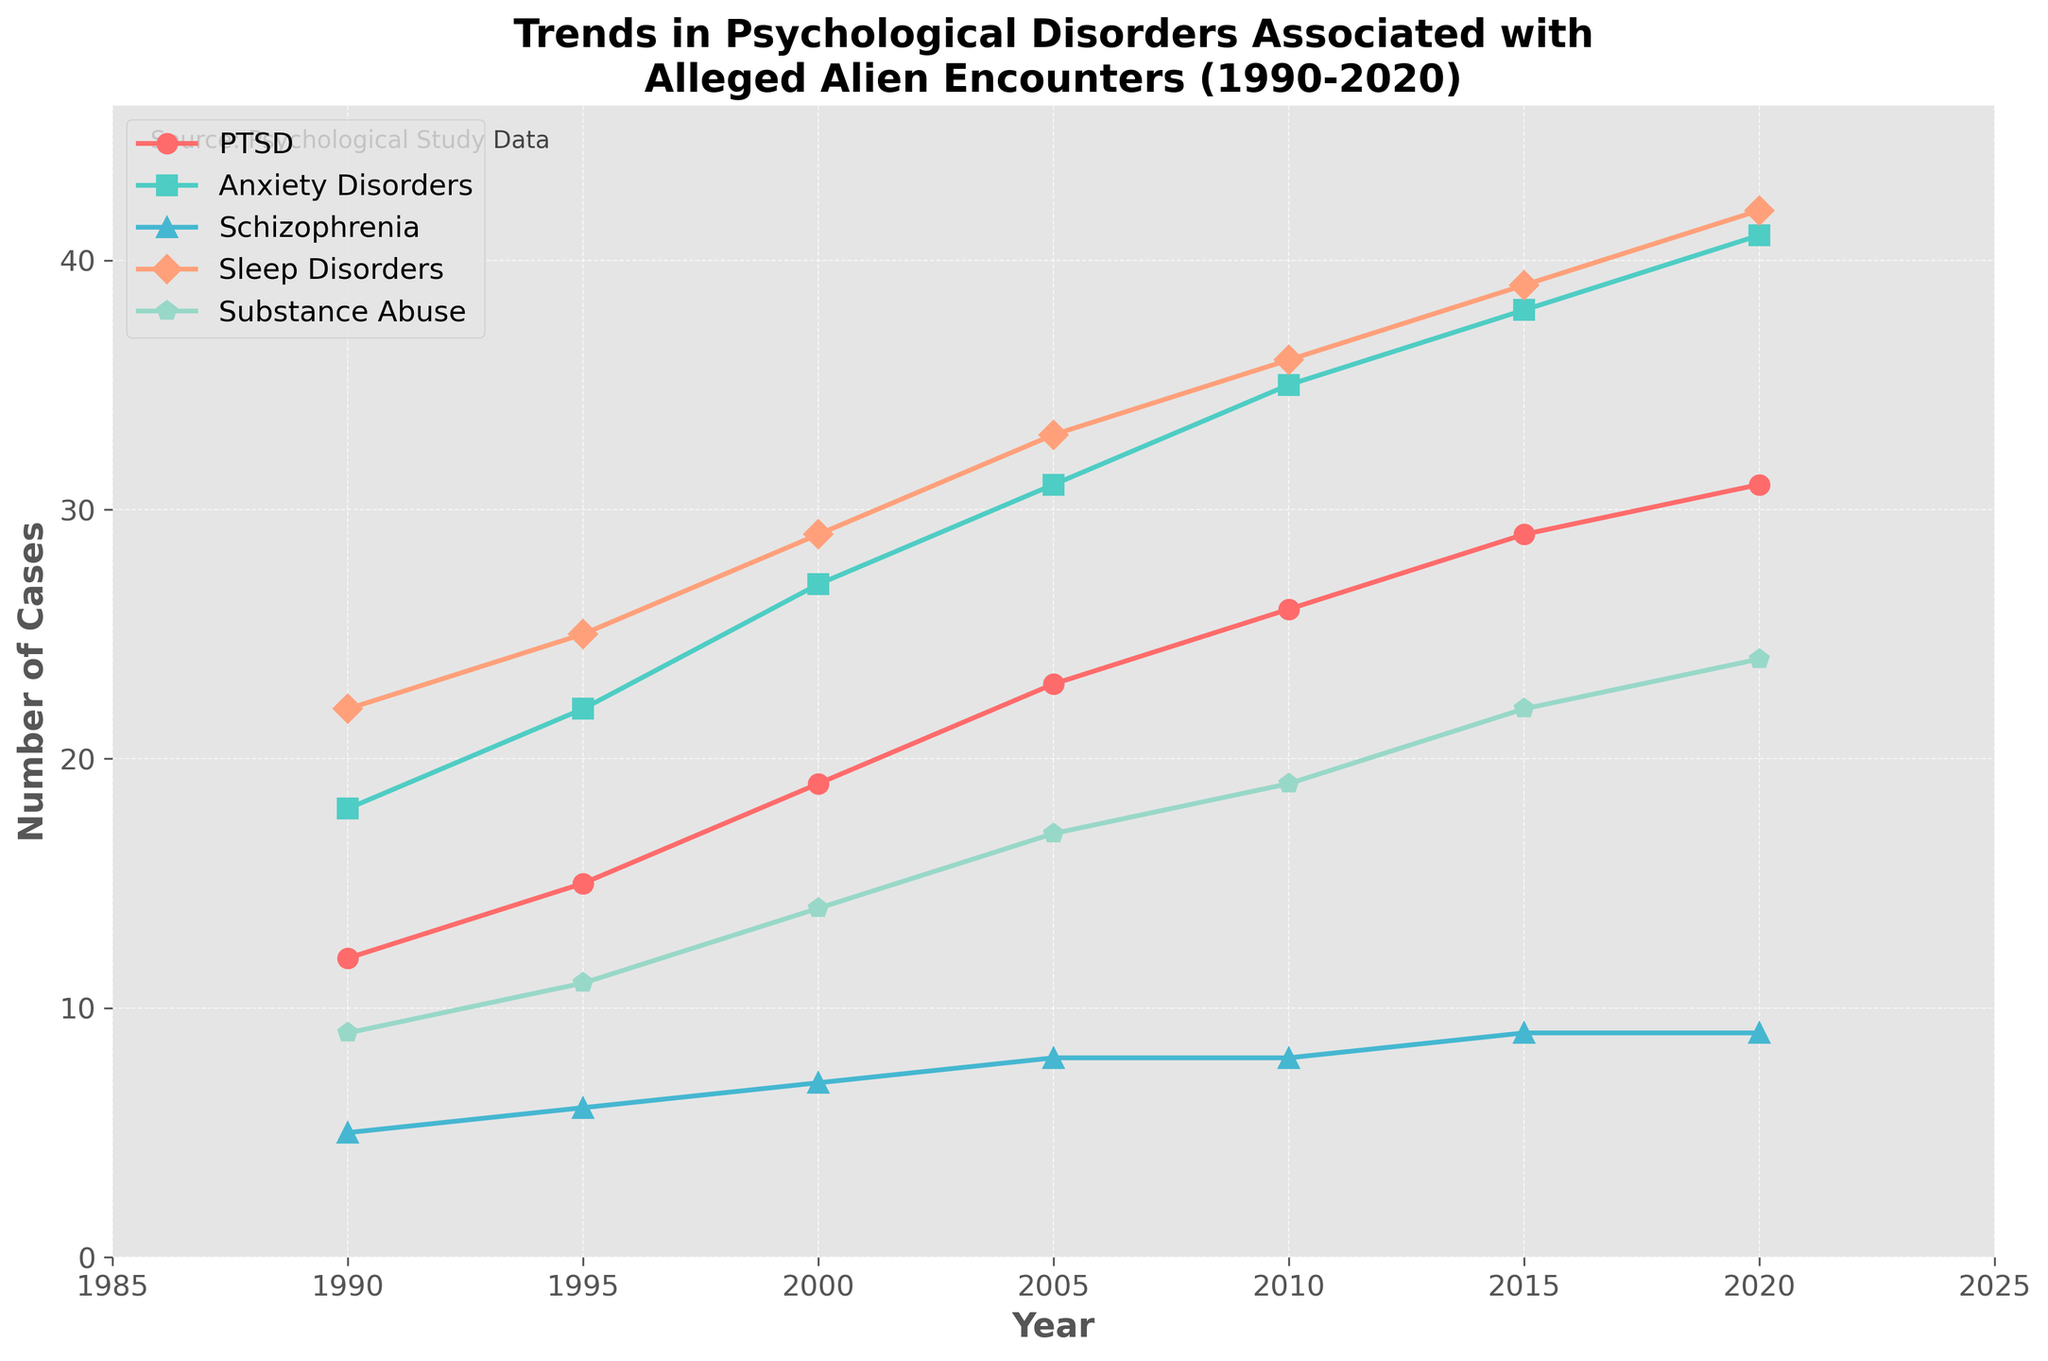What year saw the highest increase in cases of PTSD? To find the highest increase, observe the difference in PTSD cases between consecutive years and identify the maximum. The differences are 3 (1990-1995), 4 (1995-2000), 4 (2000-2005), 3 (2005-2010), 3 (2010-2015), and 2 (2015-2020). The highest increase is between 1990 and 1995.
Answer: 1990-1995 Which psychological disorder had the smallest increase in cases from 1990 to 2020? Compare the differences for all disorders between 2020 and 1990. The increases are: PTSD (31-12)=19, Anxiety Disorders (41-18)=23, Schizophrenia (9-5)=4, Sleep Disorders (42-22)=20, and Substance Abuse (24-9)=15. Schizophrenia had the smallest increase of 4 cases.
Answer: Schizophrenia In 2015, which disorder had the second highest number of cases? Look at the data for 2015 and rank the disorders by the number of cases: Sleep Disorders (39), Anxiety Disorders (38), PTSD (29), Substance Abuse (22), and Schizophrenia (9). The second highest is Anxiety Disorders with 38 cases.
Answer: Anxiety Disorders What's the average number of Sleep Disorders cases over the entire period (1990-2020)? Sum all Sleep Disorders cases and divide by the number of years: (22+25+29+33+36+39+42)/7=31
Answer: 31 Did Anxiety Disorders consistently increase every year between 1990 and 2020? Check if each year’s Anxiety Disorders cases are greater than the previous year: 18→22, 22→27, 27→31, 31→35, 35→38, 38→41. The numbers consistently increase.
Answer: Yes Which disorder showed the least variation in the number of cases over the years? Assess the range (max-min) of each disorder: anxiety (41-18)=23, PTSD (31-12)=19, schizophrenia (9-5)=4, sleep disorders (42-22)=20, substance abuse (24-9)=15. Schizophrenia has the least variation.
Answer: Schizophrenia Which disorder had more cases than PTSD in 2010? Compare the 2010 values for each disorder to PTSD's 26 cases: Anxiety Disorders (35), Sleep Disorders (36), and Substance Abuse (19). Anxiety Disorders and Sleep Disorders had more cases.
Answer: Anxiety Disorders, Sleep Disorders What's the total number of PTSD cases reported from 1990 to 2020? Sum the PTSD cases across all years: 12+15+19+23+26+29+31=155
Answer: 155 Is there any year in which Substance Abuse cases surpass those of PTSD? Compare the PTSD and Substance Abuse data for each year: 1990 (12 vs 9), 1995 (15 vs 11), 2000 (19 vs 14), 2005 (23 vs 17), 2010 (26 vs 19), 2015 (29 vs 22), 2020 (31 vs 24). No year meets this criterion.
Answer: No 